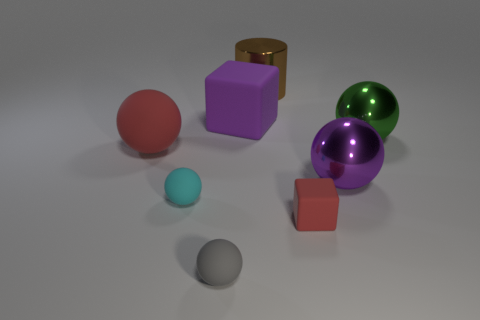Is the big purple thing on the right side of the cylinder made of the same material as the small cyan ball?
Your answer should be compact. No. Are there any other things that have the same material as the big brown cylinder?
Offer a terse response. Yes. There is a large block that is on the left side of the big sphere that is in front of the red matte ball; what number of purple things are right of it?
Your response must be concise. 1. Does the big metallic object that is behind the large green thing have the same shape as the cyan matte object?
Provide a short and direct response. No. What number of things are either purple cubes or red objects right of the cyan rubber ball?
Make the answer very short. 2. Are there more brown cylinders in front of the big rubber block than red objects?
Offer a very short reply. No. Are there the same number of red rubber spheres that are to the right of the tiny red rubber block and big green spheres that are behind the big green metal thing?
Make the answer very short. Yes. There is a metallic sphere in front of the green sphere; is there a big green ball that is on the right side of it?
Keep it short and to the point. Yes. What is the shape of the small gray rubber thing?
Your answer should be very brief. Sphere. The thing that is the same color as the big matte ball is what size?
Keep it short and to the point. Small. 